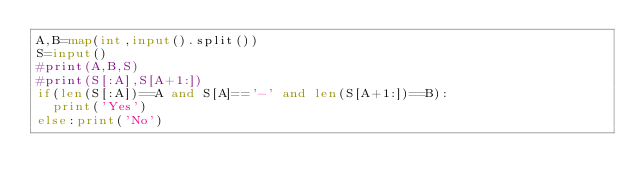Convert code to text. <code><loc_0><loc_0><loc_500><loc_500><_Python_>A,B=map(int,input().split())
S=input()
#print(A,B,S)
#print(S[:A],S[A+1:])
if(len(S[:A])==A and S[A]=='-' and len(S[A+1:])==B):
  print('Yes')
else:print('No')</code> 